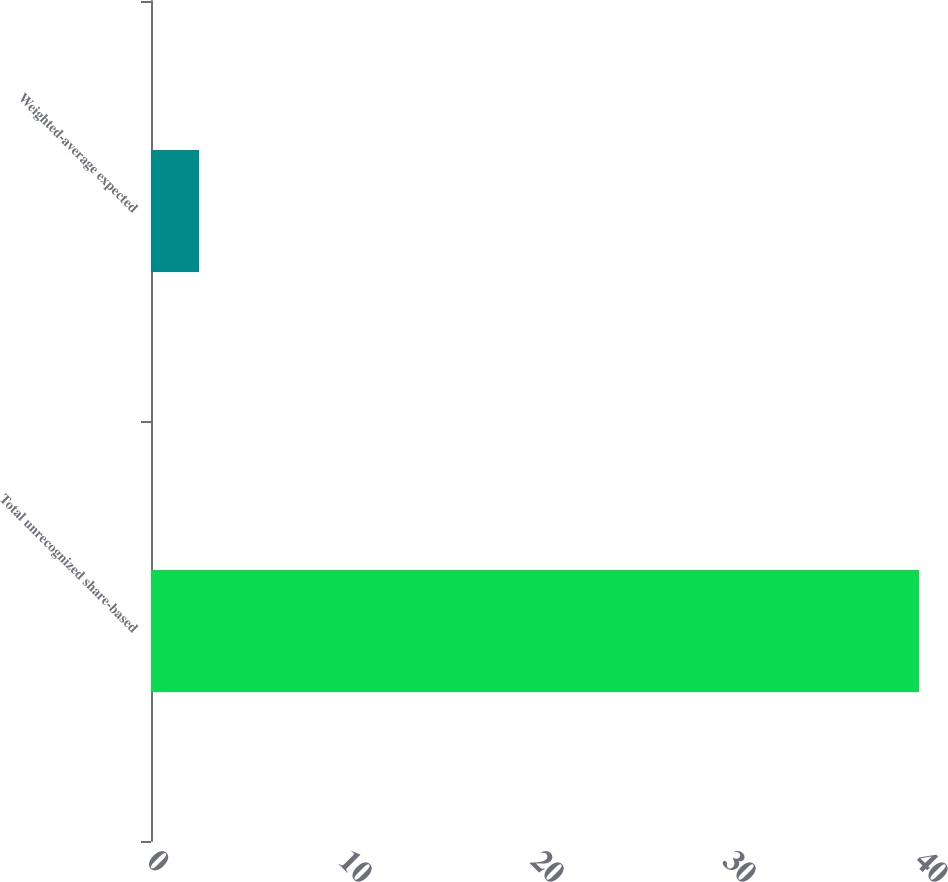Convert chart. <chart><loc_0><loc_0><loc_500><loc_500><bar_chart><fcel>Total unrecognized share-based<fcel>Weighted-average expected<nl><fcel>40<fcel>2.5<nl></chart> 